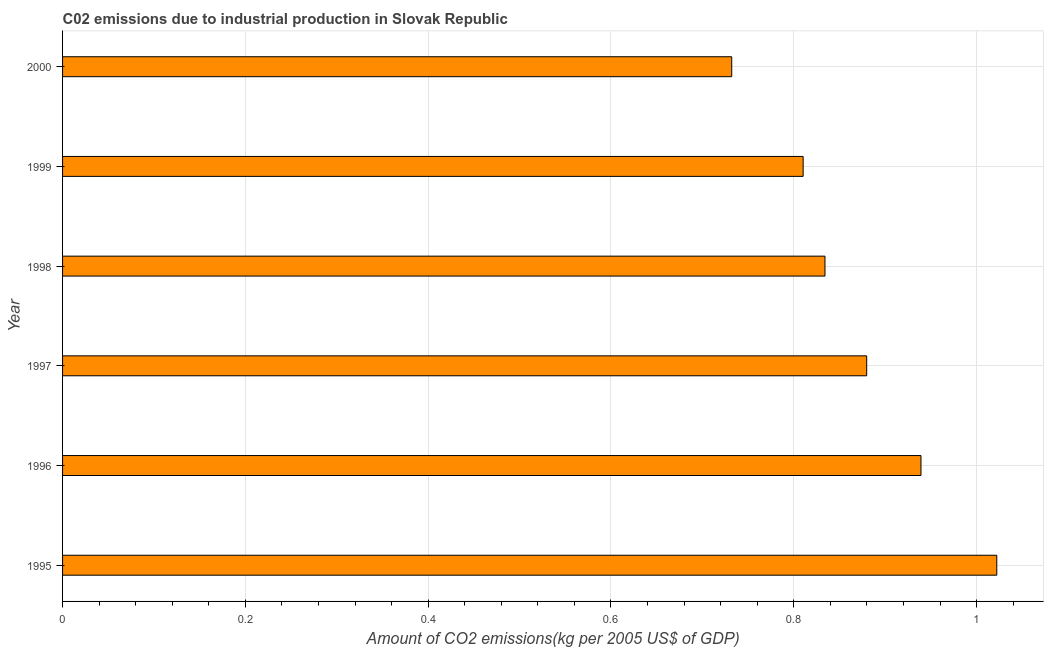Does the graph contain grids?
Offer a very short reply. Yes. What is the title of the graph?
Provide a short and direct response. C02 emissions due to industrial production in Slovak Republic. What is the label or title of the X-axis?
Make the answer very short. Amount of CO2 emissions(kg per 2005 US$ of GDP). What is the amount of co2 emissions in 1996?
Offer a very short reply. 0.94. Across all years, what is the maximum amount of co2 emissions?
Make the answer very short. 1.02. Across all years, what is the minimum amount of co2 emissions?
Give a very brief answer. 0.73. In which year was the amount of co2 emissions maximum?
Make the answer very short. 1995. In which year was the amount of co2 emissions minimum?
Your answer should be very brief. 2000. What is the sum of the amount of co2 emissions?
Your answer should be very brief. 5.22. What is the difference between the amount of co2 emissions in 1997 and 1999?
Offer a terse response. 0.07. What is the average amount of co2 emissions per year?
Give a very brief answer. 0.87. What is the median amount of co2 emissions?
Make the answer very short. 0.86. In how many years, is the amount of co2 emissions greater than 1 kg per 2005 US$ of GDP?
Offer a very short reply. 1. What is the ratio of the amount of co2 emissions in 1996 to that in 1997?
Your answer should be compact. 1.07. Is the amount of co2 emissions in 1999 less than that in 2000?
Your response must be concise. No. Is the difference between the amount of co2 emissions in 1997 and 1999 greater than the difference between any two years?
Make the answer very short. No. What is the difference between the highest and the second highest amount of co2 emissions?
Give a very brief answer. 0.08. Is the sum of the amount of co2 emissions in 1995 and 1999 greater than the maximum amount of co2 emissions across all years?
Your answer should be compact. Yes. What is the difference between the highest and the lowest amount of co2 emissions?
Provide a succinct answer. 0.29. What is the Amount of CO2 emissions(kg per 2005 US$ of GDP) of 1995?
Offer a very short reply. 1.02. What is the Amount of CO2 emissions(kg per 2005 US$ of GDP) in 1996?
Offer a terse response. 0.94. What is the Amount of CO2 emissions(kg per 2005 US$ of GDP) in 1997?
Give a very brief answer. 0.88. What is the Amount of CO2 emissions(kg per 2005 US$ of GDP) of 1998?
Your response must be concise. 0.83. What is the Amount of CO2 emissions(kg per 2005 US$ of GDP) of 1999?
Your answer should be very brief. 0.81. What is the Amount of CO2 emissions(kg per 2005 US$ of GDP) in 2000?
Make the answer very short. 0.73. What is the difference between the Amount of CO2 emissions(kg per 2005 US$ of GDP) in 1995 and 1996?
Your answer should be compact. 0.08. What is the difference between the Amount of CO2 emissions(kg per 2005 US$ of GDP) in 1995 and 1997?
Offer a very short reply. 0.14. What is the difference between the Amount of CO2 emissions(kg per 2005 US$ of GDP) in 1995 and 1998?
Provide a short and direct response. 0.19. What is the difference between the Amount of CO2 emissions(kg per 2005 US$ of GDP) in 1995 and 1999?
Your answer should be very brief. 0.21. What is the difference between the Amount of CO2 emissions(kg per 2005 US$ of GDP) in 1995 and 2000?
Ensure brevity in your answer.  0.29. What is the difference between the Amount of CO2 emissions(kg per 2005 US$ of GDP) in 1996 and 1997?
Make the answer very short. 0.06. What is the difference between the Amount of CO2 emissions(kg per 2005 US$ of GDP) in 1996 and 1998?
Make the answer very short. 0.11. What is the difference between the Amount of CO2 emissions(kg per 2005 US$ of GDP) in 1996 and 1999?
Offer a very short reply. 0.13. What is the difference between the Amount of CO2 emissions(kg per 2005 US$ of GDP) in 1996 and 2000?
Offer a terse response. 0.21. What is the difference between the Amount of CO2 emissions(kg per 2005 US$ of GDP) in 1997 and 1998?
Give a very brief answer. 0.05. What is the difference between the Amount of CO2 emissions(kg per 2005 US$ of GDP) in 1997 and 1999?
Your answer should be compact. 0.07. What is the difference between the Amount of CO2 emissions(kg per 2005 US$ of GDP) in 1997 and 2000?
Your answer should be compact. 0.15. What is the difference between the Amount of CO2 emissions(kg per 2005 US$ of GDP) in 1998 and 1999?
Ensure brevity in your answer.  0.02. What is the difference between the Amount of CO2 emissions(kg per 2005 US$ of GDP) in 1998 and 2000?
Give a very brief answer. 0.1. What is the difference between the Amount of CO2 emissions(kg per 2005 US$ of GDP) in 1999 and 2000?
Keep it short and to the point. 0.08. What is the ratio of the Amount of CO2 emissions(kg per 2005 US$ of GDP) in 1995 to that in 1996?
Give a very brief answer. 1.09. What is the ratio of the Amount of CO2 emissions(kg per 2005 US$ of GDP) in 1995 to that in 1997?
Keep it short and to the point. 1.16. What is the ratio of the Amount of CO2 emissions(kg per 2005 US$ of GDP) in 1995 to that in 1998?
Ensure brevity in your answer.  1.23. What is the ratio of the Amount of CO2 emissions(kg per 2005 US$ of GDP) in 1995 to that in 1999?
Your answer should be very brief. 1.26. What is the ratio of the Amount of CO2 emissions(kg per 2005 US$ of GDP) in 1995 to that in 2000?
Make the answer very short. 1.4. What is the ratio of the Amount of CO2 emissions(kg per 2005 US$ of GDP) in 1996 to that in 1997?
Provide a succinct answer. 1.07. What is the ratio of the Amount of CO2 emissions(kg per 2005 US$ of GDP) in 1996 to that in 1998?
Keep it short and to the point. 1.13. What is the ratio of the Amount of CO2 emissions(kg per 2005 US$ of GDP) in 1996 to that in 1999?
Make the answer very short. 1.16. What is the ratio of the Amount of CO2 emissions(kg per 2005 US$ of GDP) in 1996 to that in 2000?
Provide a short and direct response. 1.28. What is the ratio of the Amount of CO2 emissions(kg per 2005 US$ of GDP) in 1997 to that in 1998?
Give a very brief answer. 1.05. What is the ratio of the Amount of CO2 emissions(kg per 2005 US$ of GDP) in 1997 to that in 1999?
Offer a very short reply. 1.09. What is the ratio of the Amount of CO2 emissions(kg per 2005 US$ of GDP) in 1997 to that in 2000?
Give a very brief answer. 1.2. What is the ratio of the Amount of CO2 emissions(kg per 2005 US$ of GDP) in 1998 to that in 1999?
Give a very brief answer. 1.03. What is the ratio of the Amount of CO2 emissions(kg per 2005 US$ of GDP) in 1998 to that in 2000?
Offer a terse response. 1.14. What is the ratio of the Amount of CO2 emissions(kg per 2005 US$ of GDP) in 1999 to that in 2000?
Offer a terse response. 1.11. 